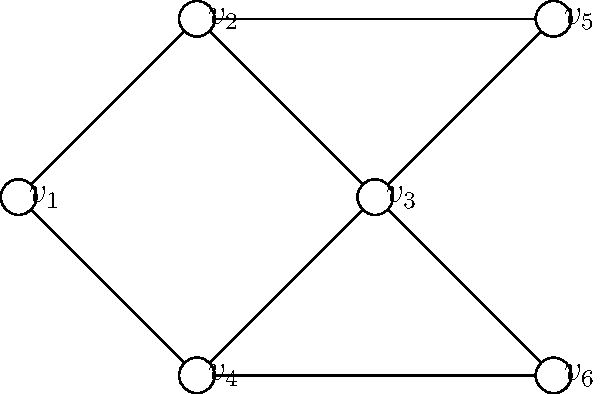Hey Anfaal, remember our graph theory classes? Here's a challenge for you! Given the graph above, what is the minimum number of colors needed to color the vertices so that no adjacent vertices share the same color? Also, can you provide a valid coloring scheme using this minimum number of colors? Let's approach this step-by-step:

1) First, we need to identify the maximum degree (number of edges connected to a vertex) in the graph. This gives us an upper bound on the number of colors needed.
   - $v_1$: degree 3
   - $v_2$: degree 2
   - $v_3$: degree 4
   - $v_4$: degree 2
   - $v_5$: degree 2
   - $v_6$: degree 2
   The maximum degree is 4 (at $v_3$).

2) According to Brooks' theorem, for a connected graph that is not a complete graph or an odd cycle, the chromatic number is at most the maximum degree.

3) Let's try to color the graph with 3 colors:
   - Start with $v_3$ (the vertex with max degree). Color it red.
   - Its neighbors ($v_1$, $v_2$, $v_4$, $v_6$) must be different colors. We can color:
     $v_1$: blue, $v_2$: green, $v_4$: blue, $v_6$: blue
   - Now $v_5$ can be colored red.

4) This coloring is valid and uses only 3 colors.

Therefore, the minimum number of colors needed is 3, and a valid coloring scheme is:
$v_1$: blue, $v_2$: green, $v_3$: red, $v_4$: blue, $v_5$: red, $v_6$: blue
Answer: 3 colors; $v_1$:blue, $v_2$:green, $v_3$:red, $v_4$:blue, $v_5$:red, $v_6$:blue 